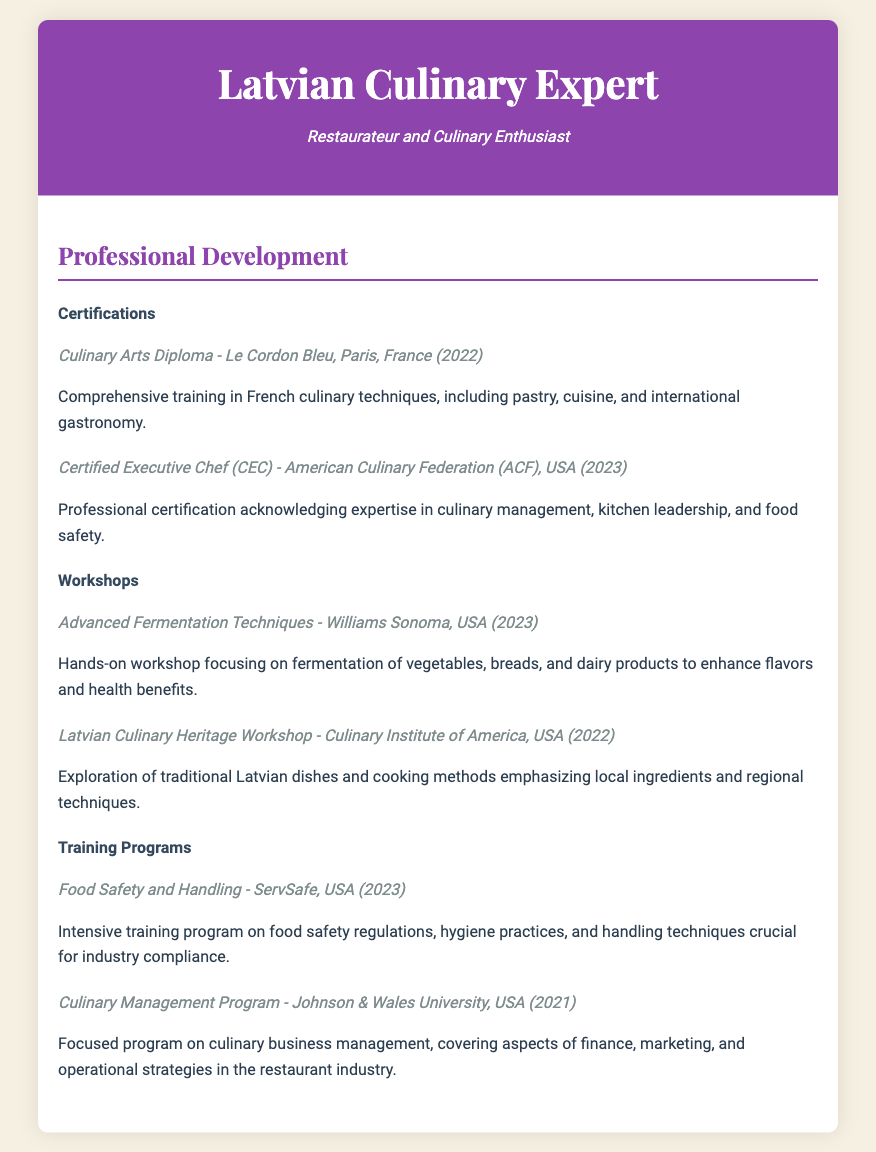What is the title of the culinary arts diploma? The title of the culinary arts diploma listed in the document is the first certification mentioned, which is "Culinary Arts Diploma."
Answer: Culinary Arts Diploma Who issued the Certified Executive Chef certification? The Certified Executive Chef certification is issued by the American Culinary Federation (ACF).
Answer: American Culinary Federation (ACF) What year was the Advanced Fermentation Techniques workshop conducted? The year indicated for the Advanced Fermentation Techniques workshop is specified within the details, which shows the publication year as 2023.
Answer: 2023 How many certifications are listed in the document? The document includes a section for certifications, and it shows two distinct certifications listed.
Answer: 2 What was the focus of the Latvian Culinary Heritage Workshop? The document describes the Latvian Culinary Heritage Workshop's focus as exploring traditional Latvian dishes and cooking methods.
Answer: Traditional Latvian dishes and cooking methods Which training program emphasizes food safety regulations? The training program mentioned that emphasizes food safety regulations is listed as "Food Safety and Handling."
Answer: Food Safety and Handling What institution conducted the Culinary Management Program? The institution that conducted the Culinary Management Program is explicitly mentioned as Johnson & Wales University.
Answer: Johnson & Wales University What location hosted the Advanced Fermentation Techniques workshop? The document states that the Advanced Fermentation Techniques workshop was hosted at Williams Sonoma.
Answer: Williams Sonoma What is the overall theme of the Professional Development section? The overall theme of the Professional Development section includes certifications, workshops, and training programs aimed at enhancing culinary skills.
Answer: Enhancing culinary skills 